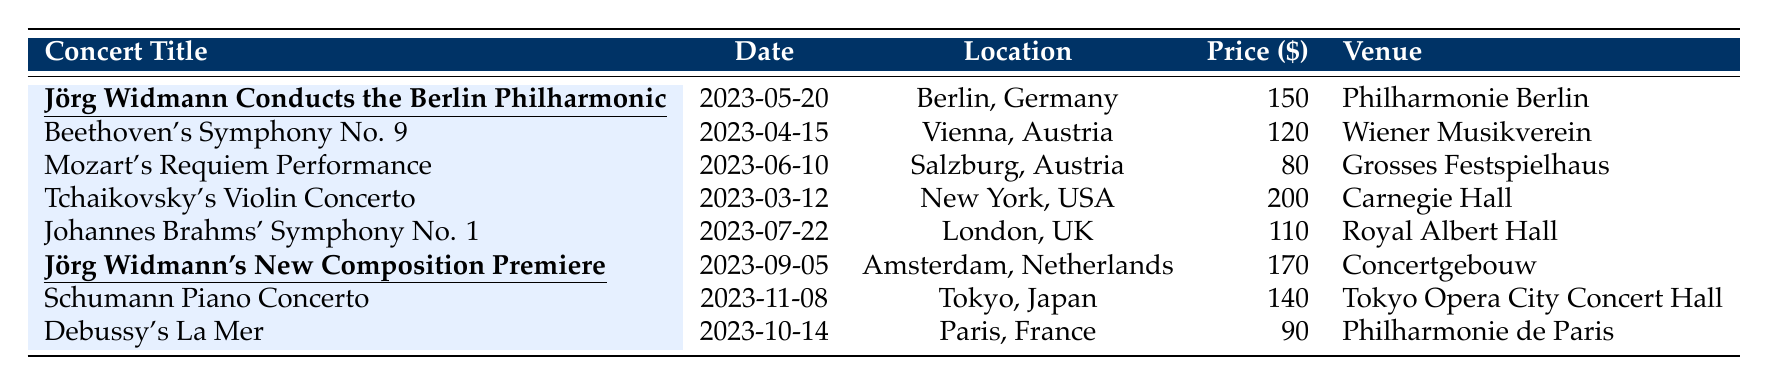What is the ticket price for "Jörg Widmann Conducts the Berlin Philharmonic"? The ticket price is directly listed in the table next to this concert, which shows a price of $150.
Answer: 150 Which concert has the highest ticket price? Scanning through the ticket prices, the highest price is $200 for "Tchaikovsky's Violin Concerto".
Answer: Tchaikovsky's Violin Concerto What is the total ticket price of Jörg Widmann's concerts? The two concerts are "Jörg Widmann Conducts the Berlin Philharmonic" at $150 and "Jörg Widmann's New Composition Premiere" at $170. Summing these gives: 150 + 170 = 320.
Answer: 320 How much more expensive is "Tchaikovsky's Violin Concerto" compared to "Mozart's Requiem Performance"? The prices are $200 and $80, respectively. The difference is calculated by subtracting: 200 - 80 = 120.
Answer: 120 Is the ticket price for "Debussy's La Mer" less than $100? The ticket price for "Debussy's La Mer" is $90, which is indeed less than $100.
Answer: Yes What is the average ticket price of the concerts listed? To find the average, sum all ticket prices: 150 + 120 + 80 + 200 + 110 + 170 + 140 + 90 = 1,120. There are 8 concerts, so the average is: 1,120 / 8 = 140.
Answer: 140 Which concert takes place last in the year and what is its ticket price? The last concert listed is "Schumann Piano Concerto" on 2023-11-08 with a ticket price of $140.
Answer: Schumann Piano Concerto, 140 How many concerts have ticket prices above $150? The concerts exceeding $150 are "Tchaikovsky's Violin Concerto" ($200) and "Jörg Widmann's New Composition Premiere" ($170), totaling 2 concerts.
Answer: 2 What is the range of ticket prices for all concerts? The highest price is $200 and the lowest price is $80. Thus, the range is calculated by: 200 - 80 = 120.
Answer: 120 Does the concert in Tokyo have a ticket price higher than the concert in Paris? The ticket price for "Schumann Piano Concerto" in Tokyo is $140, and for "Debussy's La Mer" in Paris, it is $90. Since 140 > 90, the answer is yes.
Answer: Yes 